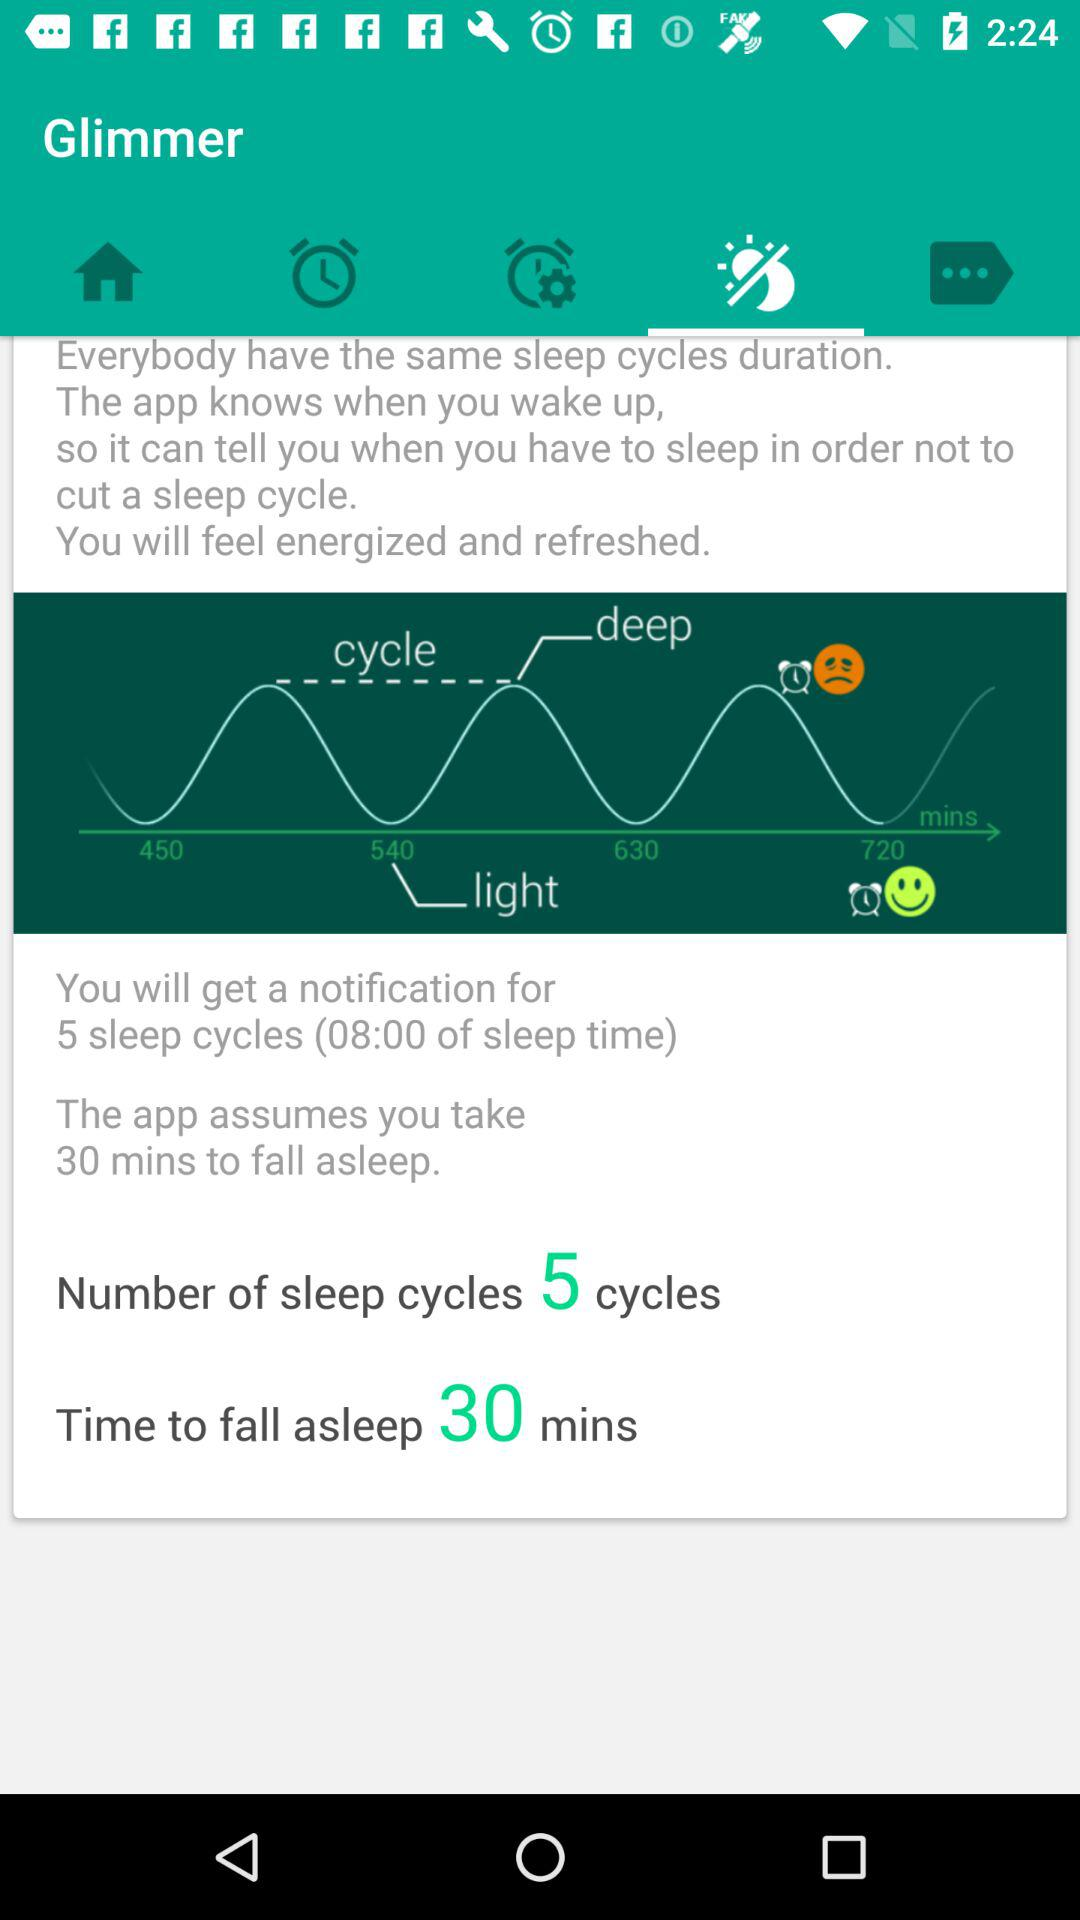What is the number of sleep cycles? The number of sleep cycles is 5. 